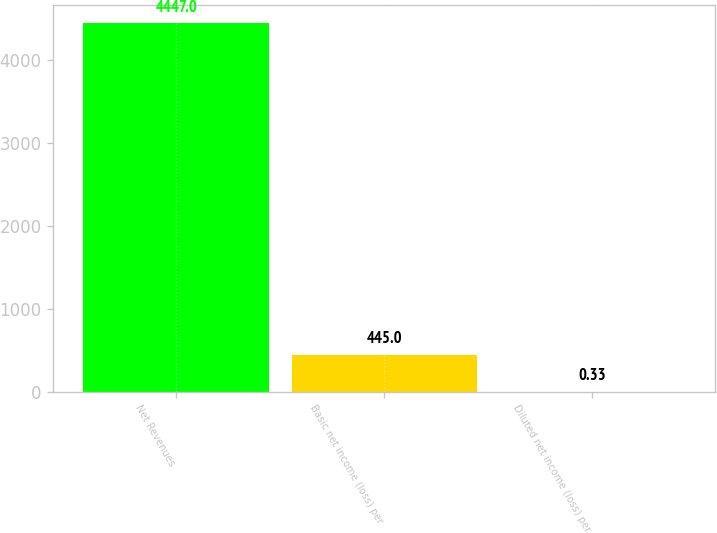Convert chart to OTSL. <chart><loc_0><loc_0><loc_500><loc_500><bar_chart><fcel>Net Revenues<fcel>Basic net income (loss) per<fcel>Diluted net income (loss) per<nl><fcel>4447<fcel>445<fcel>0.33<nl></chart> 